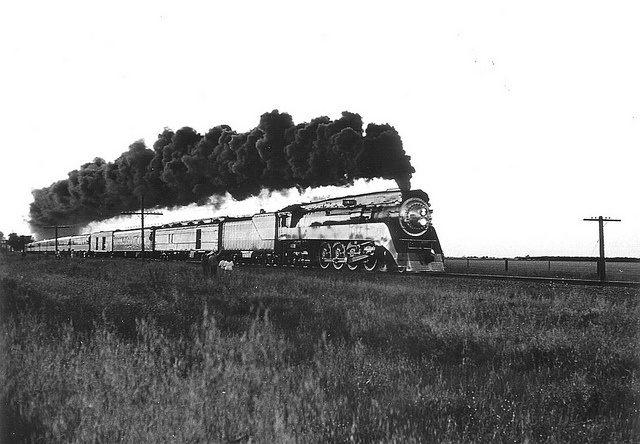Describe the objects in this image and their specific colors. I can see a train in white, black, gainsboro, darkgray, and gray tones in this image. 